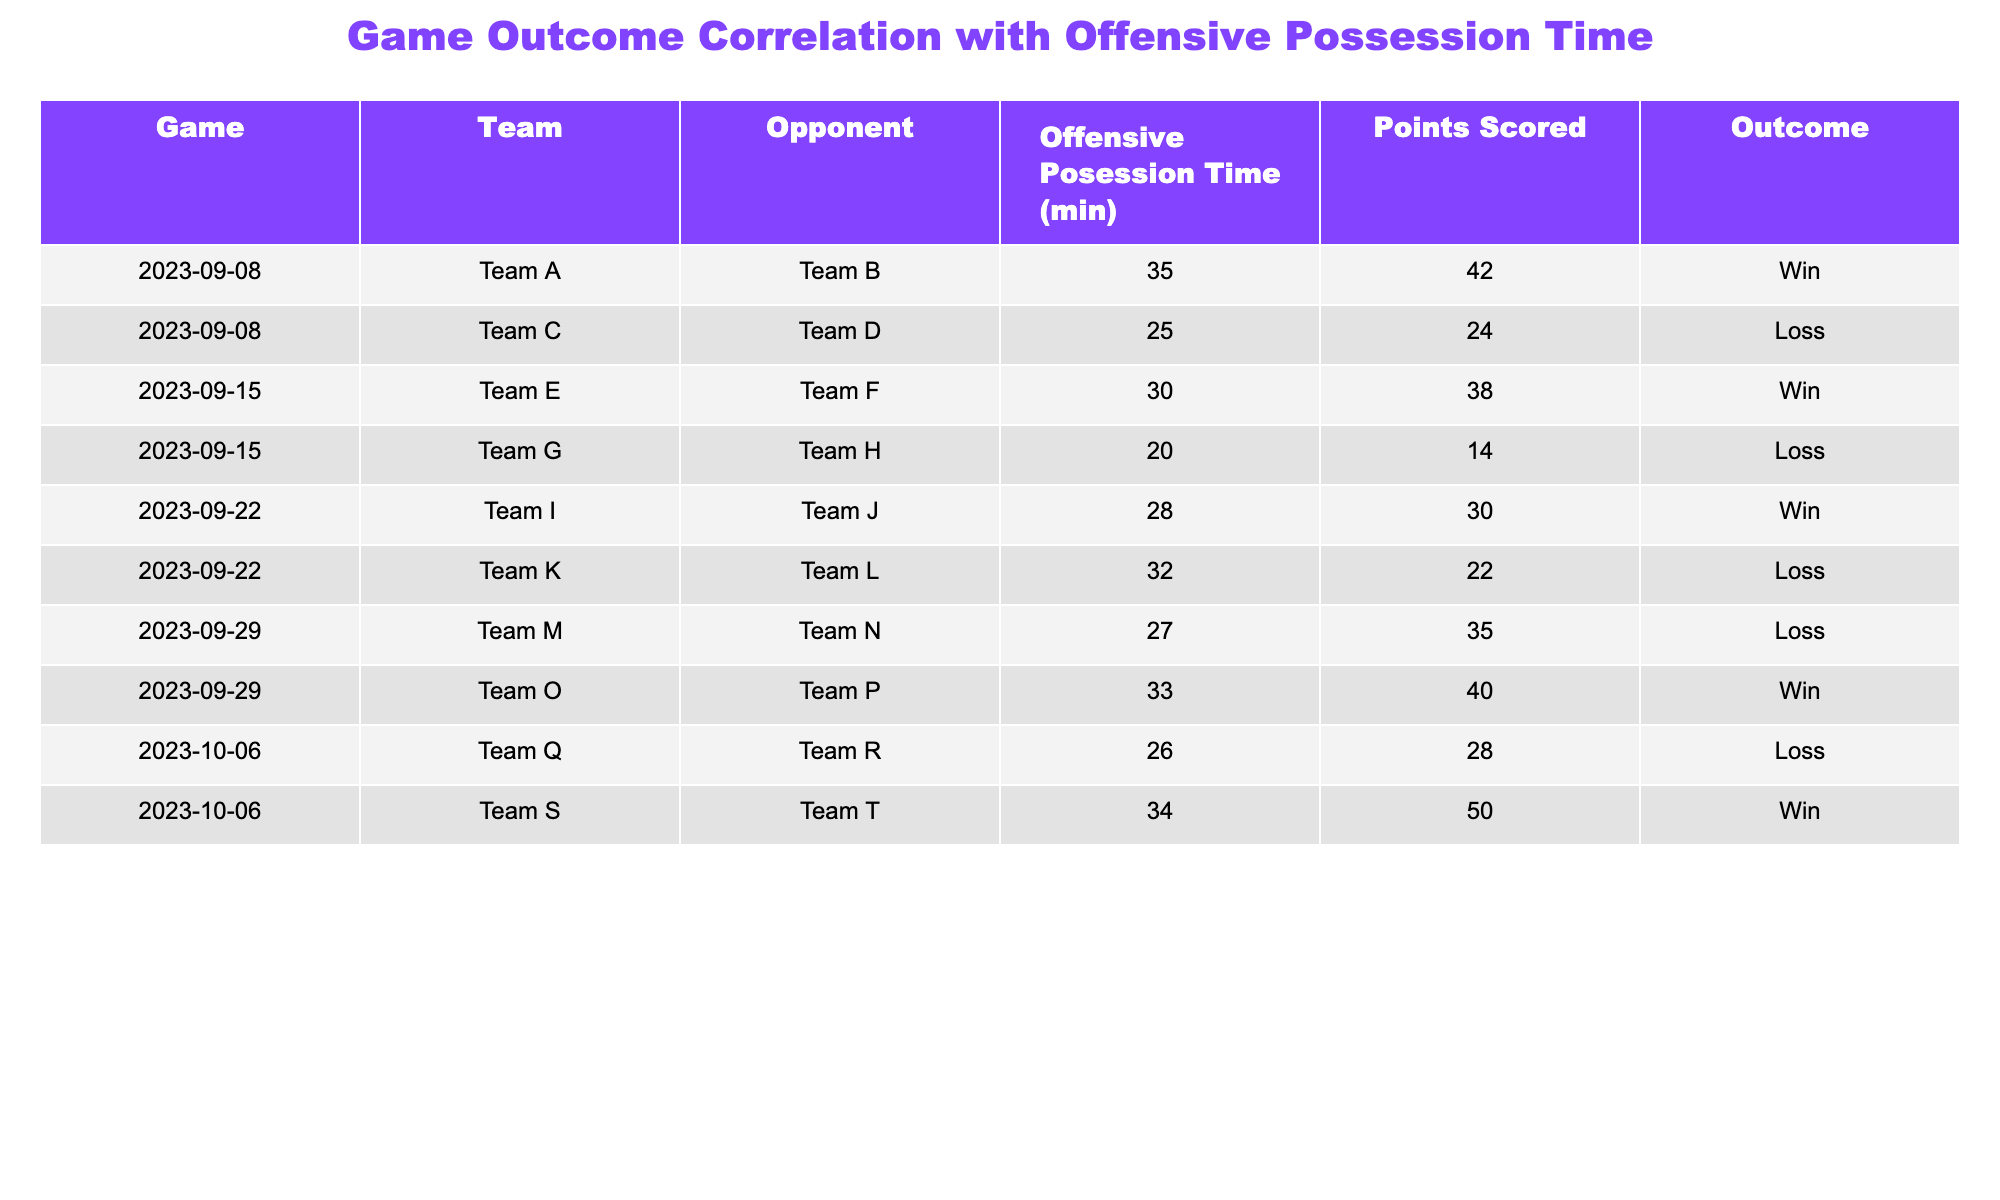What is the highest offensive possession time recorded in the table? The highest offensive possession time can be found by scanning the "Offensive Possession Time (min)" column. The maximum time listed is 35 minutes, corresponding to Team A's game against Team B.
Answer: 35 Which team scored the most points in a loss? By examining the "Points Scored" column for the games that resulted in a "Loss," the highest number of points scored is 35 by Team M in their game against Team N.
Answer: 35 What is the average points scored by teams that won their games? To find the average points scored by winning teams, we first identify the teams that won: Team A (42), Team E (38), Team I (30), Team O (40), and Team S (50). The sum of their points is (42 + 38 + 30 + 40 + 50) = 200. There are 5 winning teams, so the average is 200 / 5 = 40.
Answer: 40 Did any team lose while having more offensive possession time than their opponent? We can compare each loss to the opponent's offensive possession time. The losses for Team C, Team G, Team K, and Team M indicate a loss despite having less possession time than their opponents. For instance, Team C (25 min) lost to Team D (not shown), and Team G (20 min) lost to Team H. Therefore, no team lost while having more possession.
Answer: No Which team had the second-highest points scored in a win? We first list the winning teams' points: Team A (42), Team E (38), Team I (30), Team O (40), Team S (50). Sorting these points gives us 50, 42, 40, 38, and 30. The second-highest points scored in a win is Team O's 40 points.
Answer: 40 Was there any game where the losing team scored more points than 30? By checking the "Points Scored" for rows marked as "Loss," we see that Team M (35) and Team C (24) are the only teams that lost, and Team M scored over 30 points. Therefore, there was a game where the losing team scored more than 30 points.
Answer: Yes What is the difference in points scored between the highest and lowest scoring winning team? The highest scoring winning team is Team S with 50 points, and the lowest is Team I with 30 points. The difference is calculated as 50 - 30 = 20, which reveals a significant difference in performance between the two.
Answer: 20 How many teams scored 30 points or less in their losses? Checking the points of the losing teams: Team C (24), Team G (14), Team K (22), and Team M (35), we find that Team C, Team G, and Team K scored 30 points or less, totaling three teams.
Answer: 3 Is there a correlation between offensive possession time and points scored based on the outcomes? To analyze correlation, we see that teams with more possession time generally scored more points in wins (Team A, Team S) compared to losses (Team C, Team G). Therefore, overall, more offensive possession tends to align with winning and higher scores.
Answer: Yes 